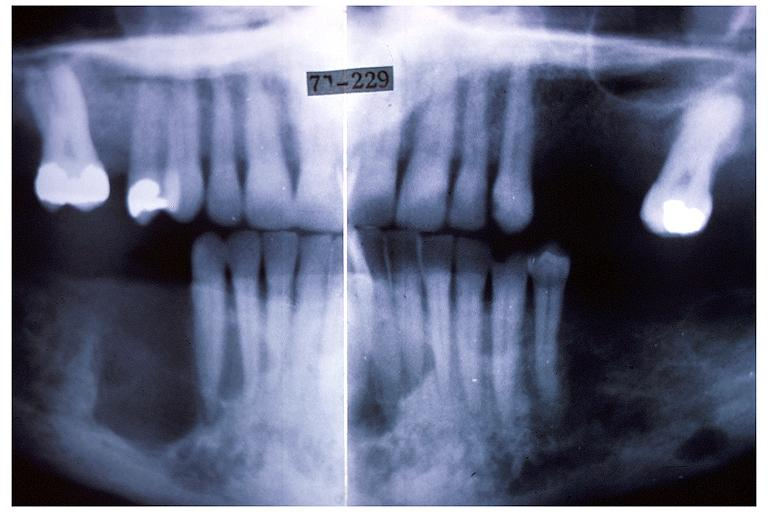s edema present?
Answer the question using a single word or phrase. No 